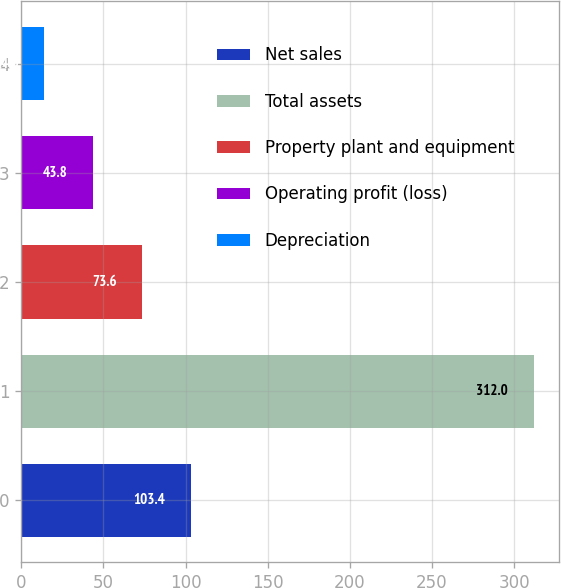Convert chart. <chart><loc_0><loc_0><loc_500><loc_500><bar_chart><fcel>Net sales<fcel>Total assets<fcel>Property plant and equipment<fcel>Operating profit (loss)<fcel>Depreciation<nl><fcel>103.4<fcel>312<fcel>73.6<fcel>43.8<fcel>14<nl></chart> 